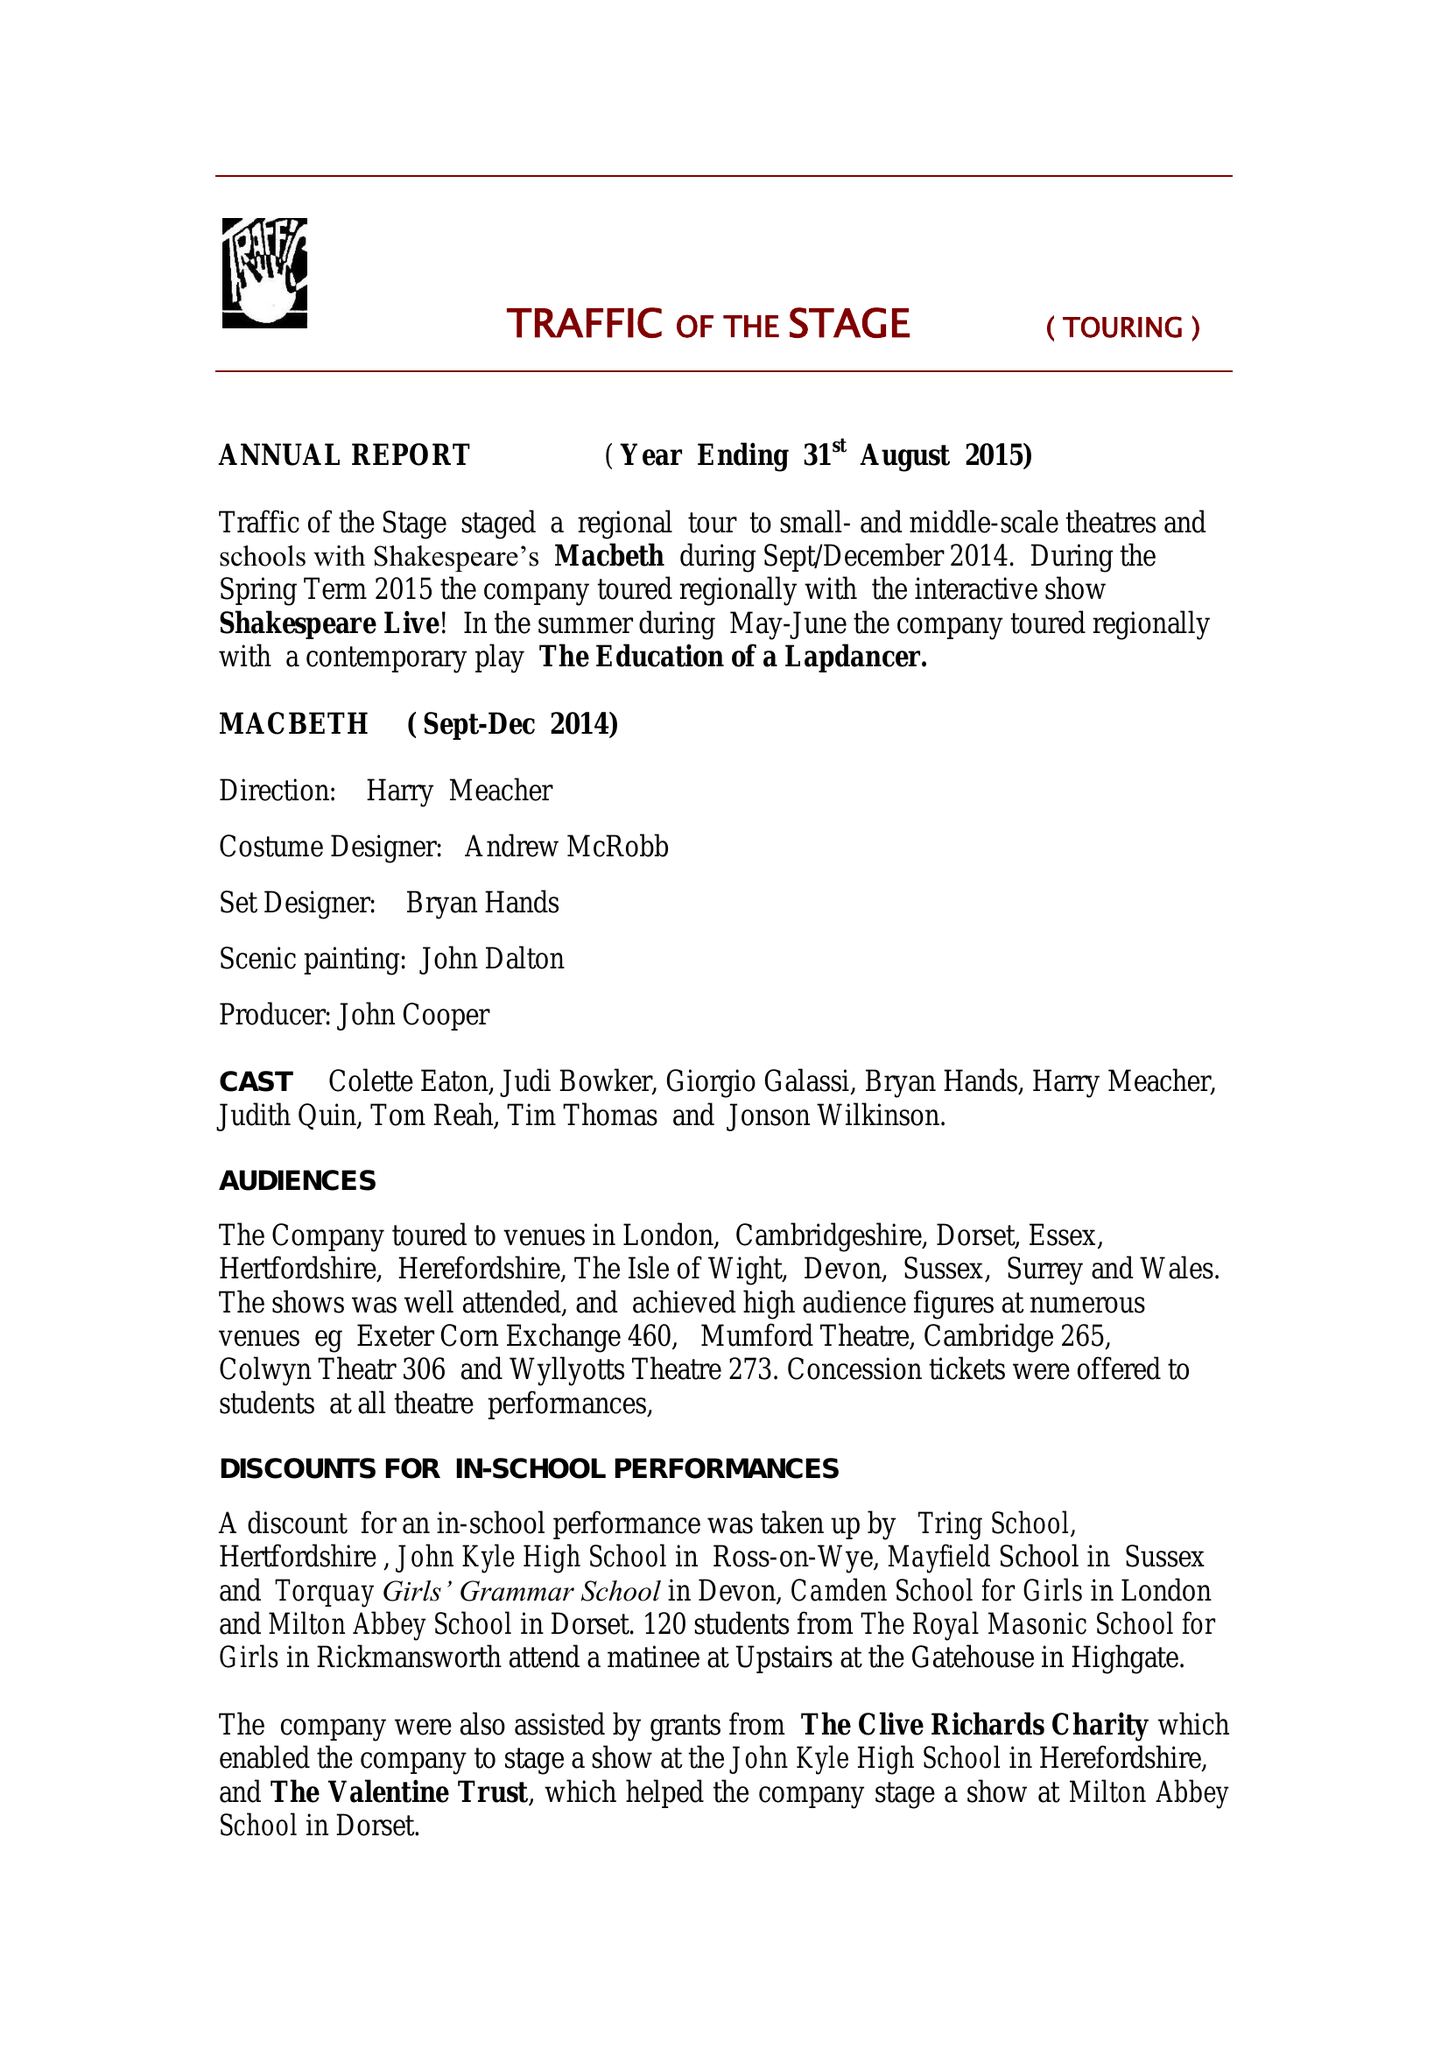What is the value for the charity_number?
Answer the question using a single word or phrase. 1096016 